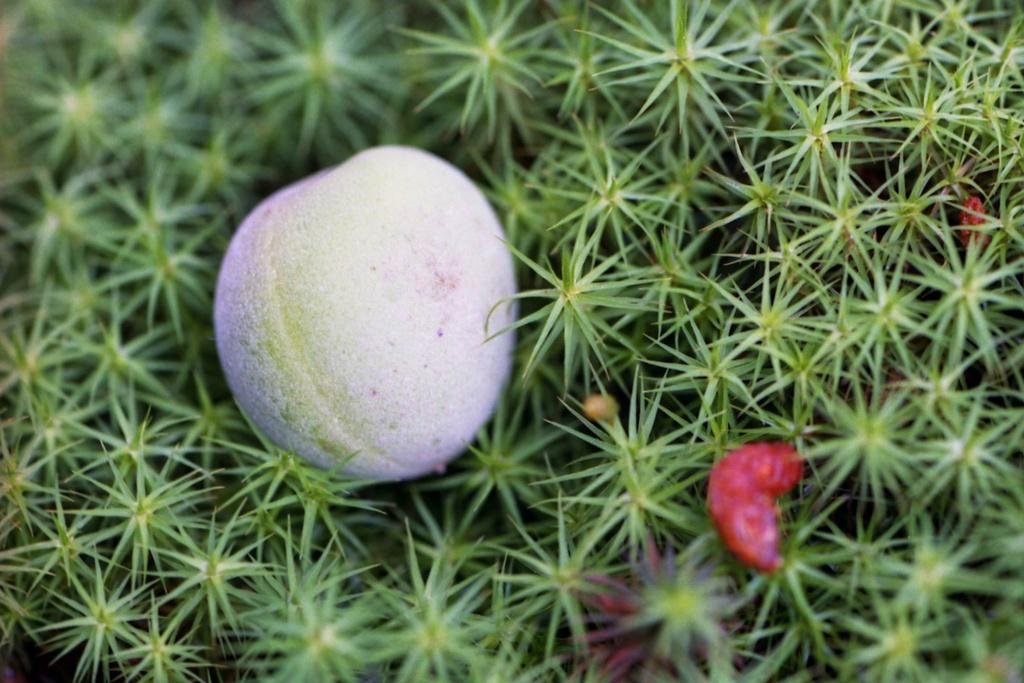What is located in the center of the image? There is a fruit on the ground in the center of the image. Can you describe the fruit in the image? Unfortunately, the specific type of fruit cannot be determined from the image alone. What team is responsible for picking up the fruit in the image? There is no team present in the image, as it only shows a fruit on the ground. 